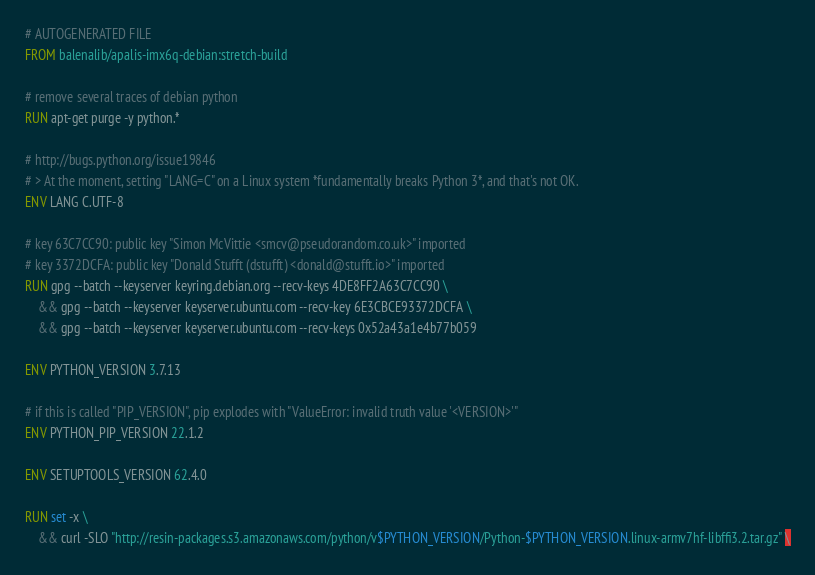<code> <loc_0><loc_0><loc_500><loc_500><_Dockerfile_># AUTOGENERATED FILE
FROM balenalib/apalis-imx6q-debian:stretch-build

# remove several traces of debian python
RUN apt-get purge -y python.*

# http://bugs.python.org/issue19846
# > At the moment, setting "LANG=C" on a Linux system *fundamentally breaks Python 3*, and that's not OK.
ENV LANG C.UTF-8

# key 63C7CC90: public key "Simon McVittie <smcv@pseudorandom.co.uk>" imported
# key 3372DCFA: public key "Donald Stufft (dstufft) <donald@stufft.io>" imported
RUN gpg --batch --keyserver keyring.debian.org --recv-keys 4DE8FF2A63C7CC90 \
    && gpg --batch --keyserver keyserver.ubuntu.com --recv-key 6E3CBCE93372DCFA \
    && gpg --batch --keyserver keyserver.ubuntu.com --recv-keys 0x52a43a1e4b77b059

ENV PYTHON_VERSION 3.7.13

# if this is called "PIP_VERSION", pip explodes with "ValueError: invalid truth value '<VERSION>'"
ENV PYTHON_PIP_VERSION 22.1.2

ENV SETUPTOOLS_VERSION 62.4.0

RUN set -x \
    && curl -SLO "http://resin-packages.s3.amazonaws.com/python/v$PYTHON_VERSION/Python-$PYTHON_VERSION.linux-armv7hf-libffi3.2.tar.gz" \</code> 